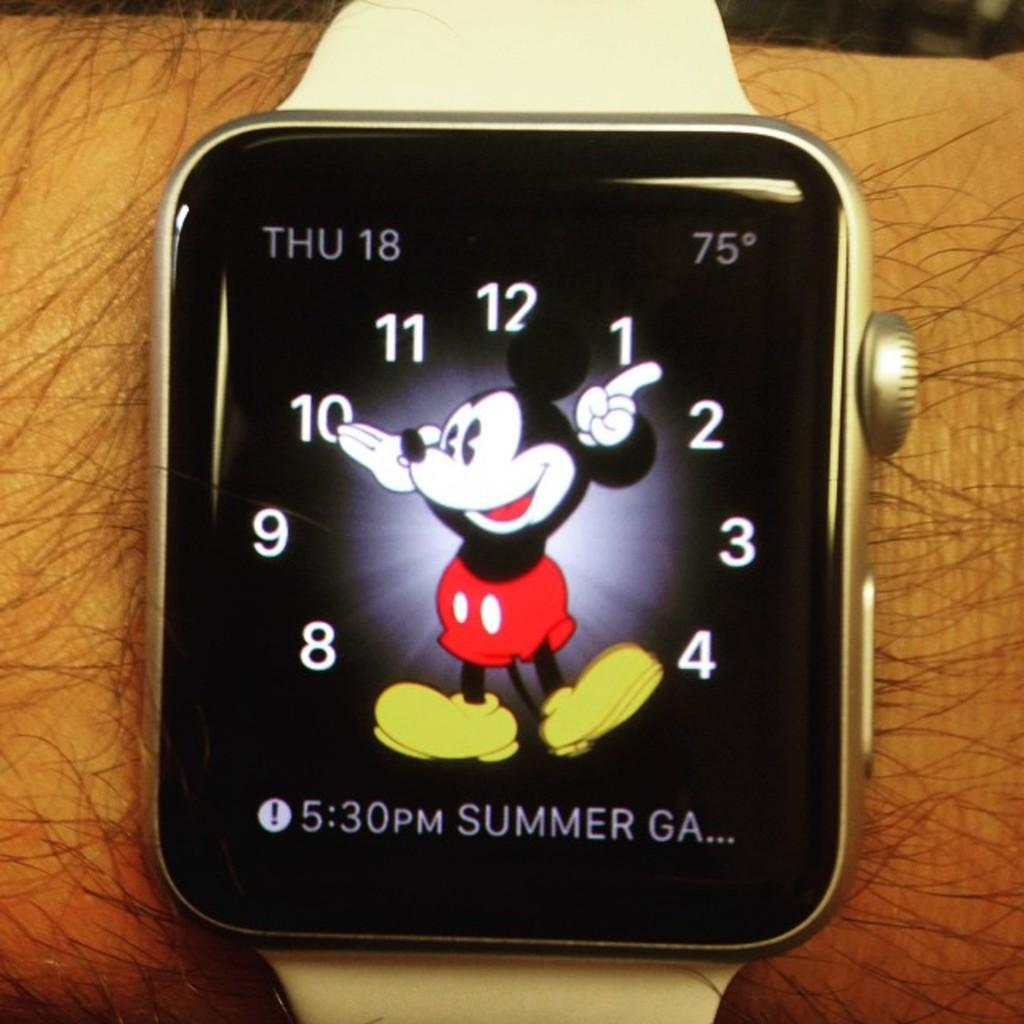<image>
Describe the image concisely. A watch with Mickey Mouse on it says that the date is Thursday 18. 